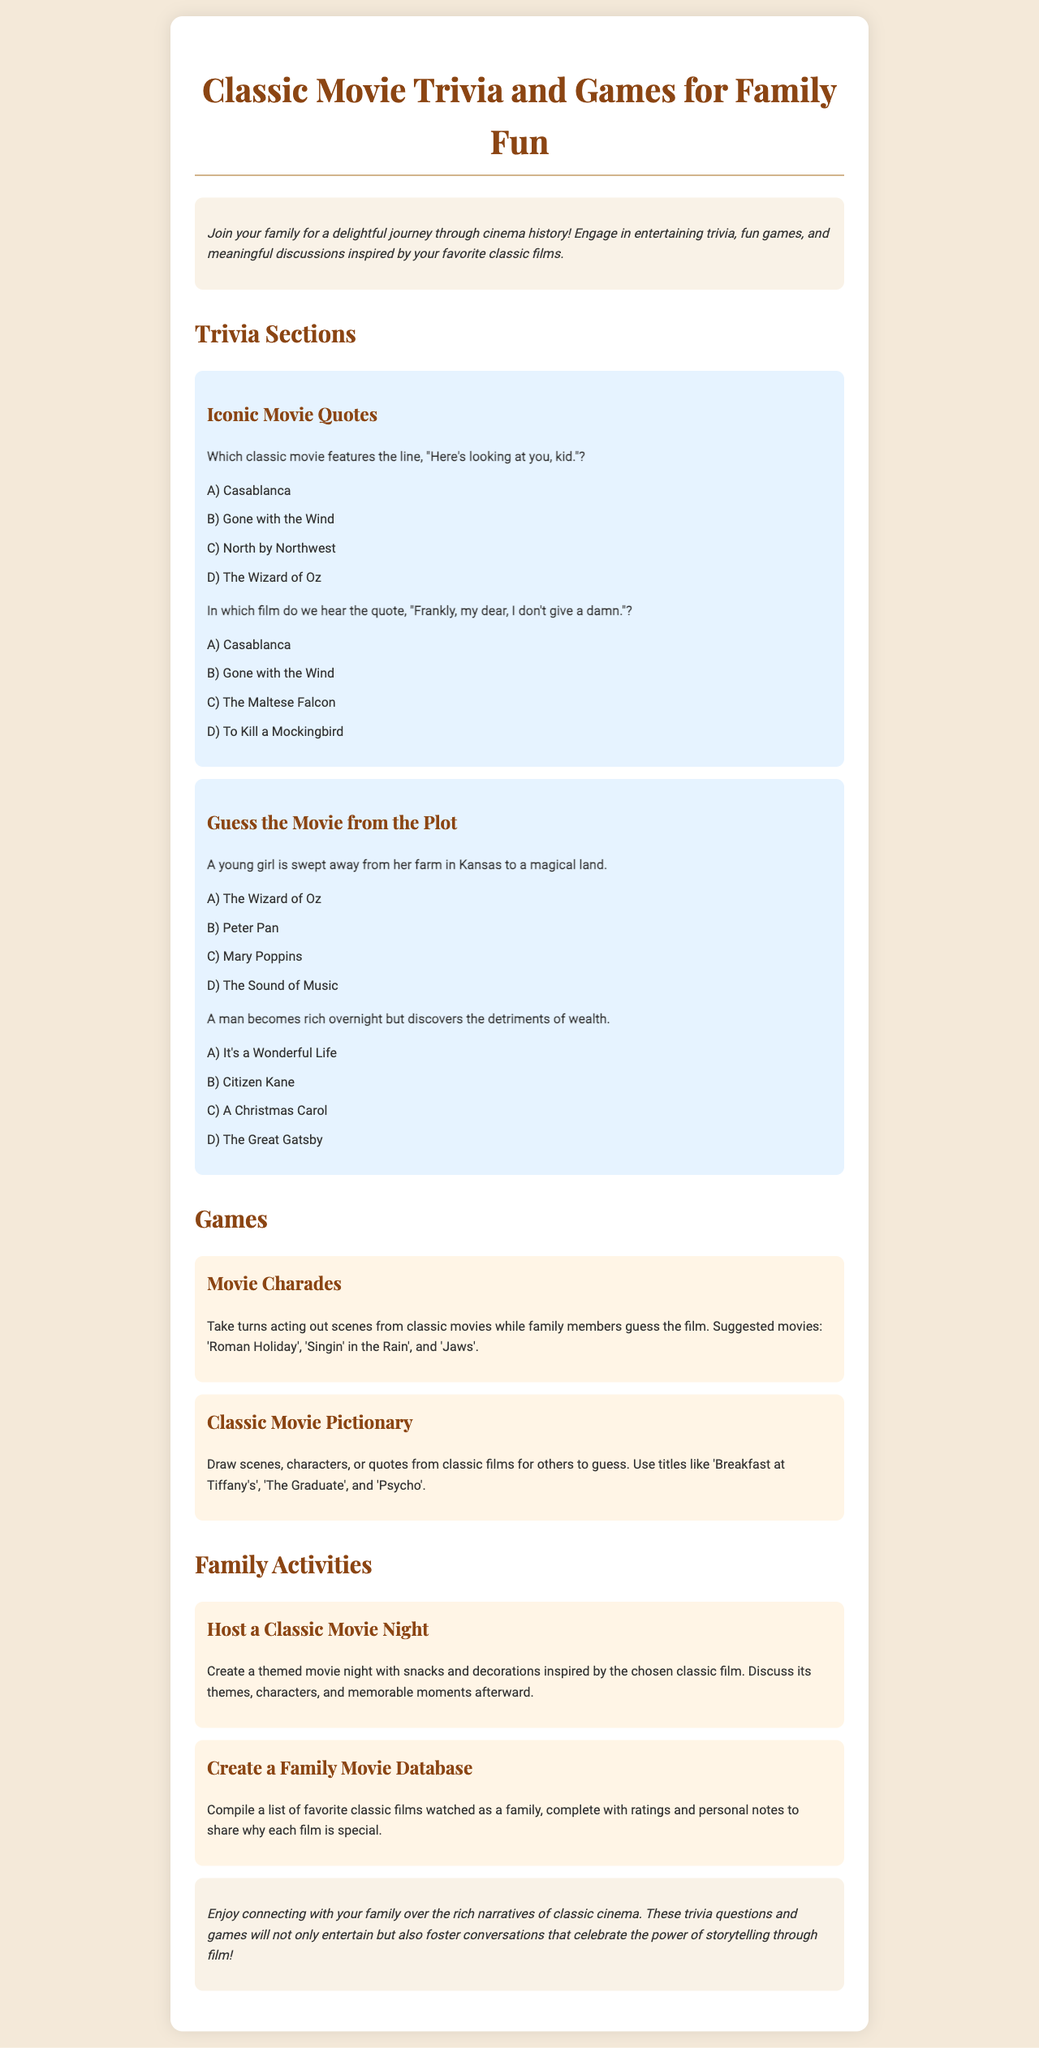What is the title of the brochure? The title of the brochure is prominently displayed at the top, which is "Classic Movie Trivia and Games for Family Fun".
Answer: Classic Movie Trivia and Games for Family Fun What is the theme of the trivia sections? The trivia sections focus on specific aspects of classic films, such as quotes and plots from these films.
Answer: Iconic Movie Quotes and Guess the Movie from the Plot Name one suggested movie for Movie Charades. One of the suggested movies for Movie Charades is 'Roman Holiday' as mentioned in the document.
Answer: Roman Holiday What is one activity families can do together according to the brochure? The brochure mentions creating a themed movie night as an engaging family activity.
Answer: Host a Classic Movie Night How many quotes are provided under Iconic Movie Quotes? There are two quotes provided under the Iconic Movie Quotes section in the trivia.
Answer: 2 What is the purpose of the trivia questions and games? The trivia questions and games are designed to entertain and foster conversations around classic films.
Answer: Connecting with family through classic films Which movie features the quote, "Frankly, my dear, I don't give a damn."? The quiz specifies that this quote is from "Gone with the Wind".
Answer: Gone with the Wind What type of font is used for headings in the brochure? The brochure uses 'Playfair Display' font for the headings, creating a stylistic contrast.
Answer: Playfair Display 